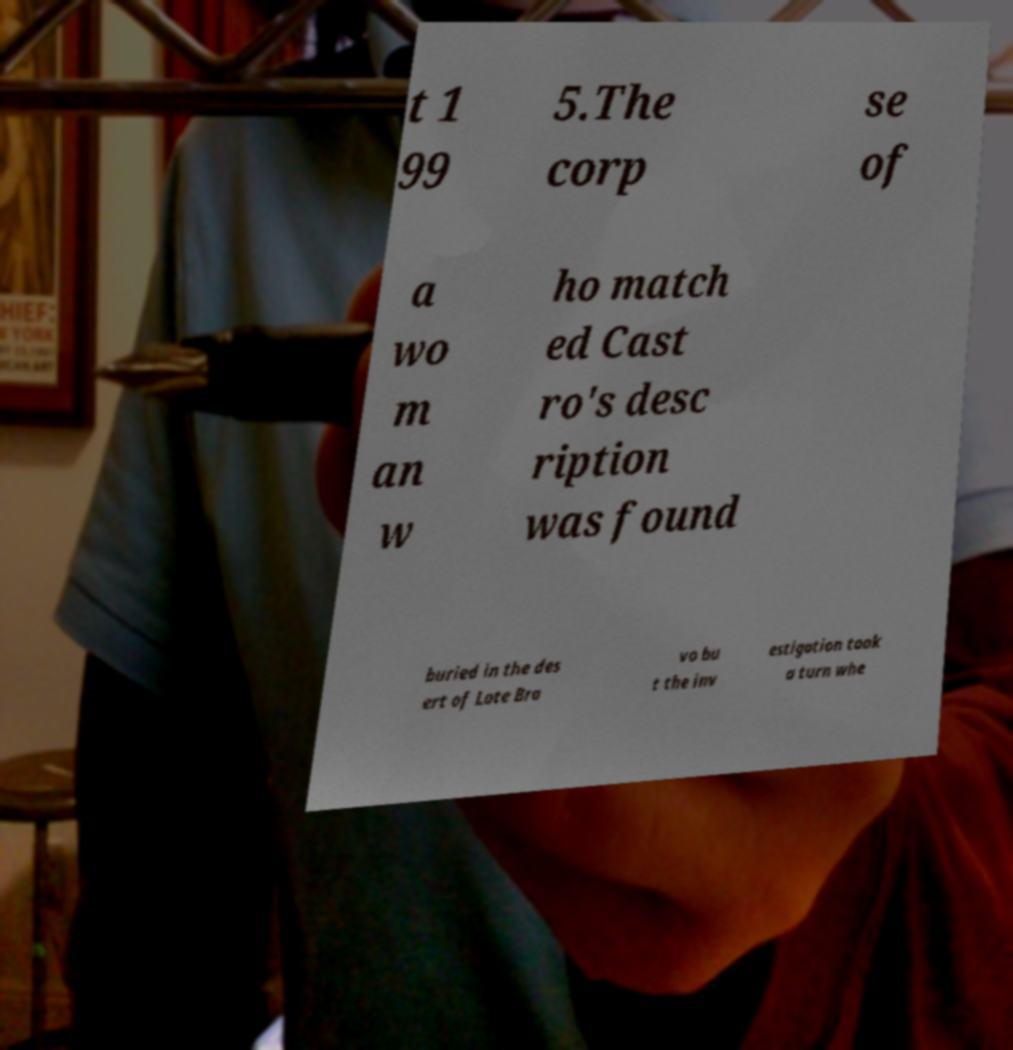There's text embedded in this image that I need extracted. Can you transcribe it verbatim? t 1 99 5.The corp se of a wo m an w ho match ed Cast ro's desc ription was found buried in the des ert of Lote Bra vo bu t the inv estigation took a turn whe 